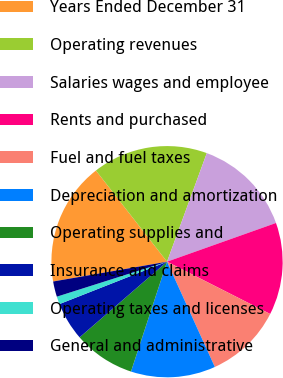<chart> <loc_0><loc_0><loc_500><loc_500><pie_chart><fcel>Years Ended December 31<fcel>Operating revenues<fcel>Salaries wages and employee<fcel>Rents and purchased<fcel>Fuel and fuel taxes<fcel>Depreciation and amortization<fcel>Operating supplies and<fcel>Insurance and claims<fcel>Operating taxes and licenses<fcel>General and administrative<nl><fcel>17.2%<fcel>16.13%<fcel>13.98%<fcel>12.9%<fcel>10.75%<fcel>11.83%<fcel>8.6%<fcel>5.38%<fcel>1.08%<fcel>2.15%<nl></chart> 